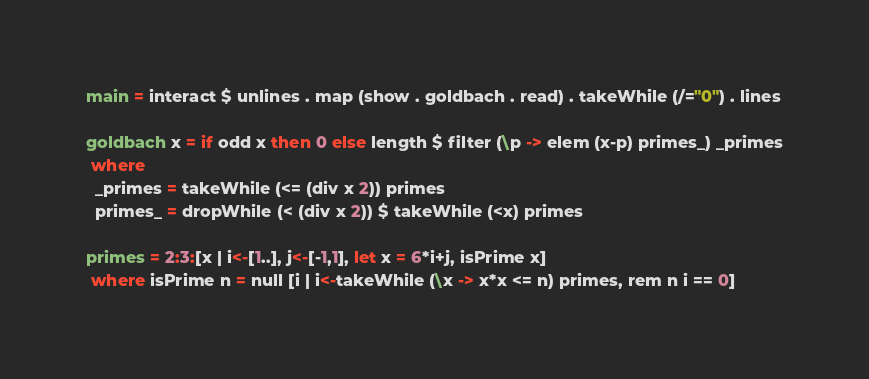<code> <loc_0><loc_0><loc_500><loc_500><_Haskell_>main = interact $ unlines . map (show . goldbach . read) . takeWhile (/="0") . lines

goldbach x = if odd x then 0 else length $ filter (\p -> elem (x-p) primes_) _primes
 where
  _primes = takeWhile (<= (div x 2)) primes
  primes_ = dropWhile (< (div x 2)) $ takeWhile (<x) primes

primes = 2:3:[x | i<-[1..], j<-[-1,1], let x = 6*i+j, isPrime x]
 where isPrime n = null [i | i<-takeWhile (\x -> x*x <= n) primes, rem n i == 0]</code> 